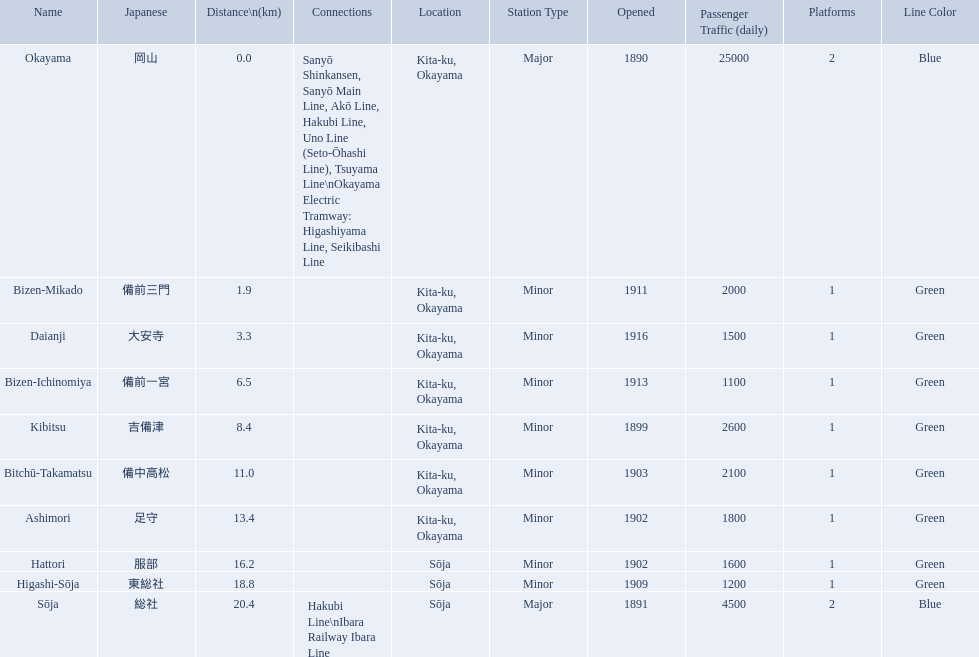What are all of the train names? Okayama, Bizen-Mikado, Daianji, Bizen-Ichinomiya, Kibitsu, Bitchū-Takamatsu, Ashimori, Hattori, Higashi-Sōja, Sōja. What is the distance for each? 0.0, 1.9, 3.3, 6.5, 8.4, 11.0, 13.4, 16.2, 18.8, 20.4. And which train's distance is between 1 and 2 km? Bizen-Mikado. What are all the stations on the kibi line? Okayama, Bizen-Mikado, Daianji, Bizen-Ichinomiya, Kibitsu, Bitchū-Takamatsu, Ashimori, Hattori, Higashi-Sōja, Sōja. What are the distances of these stations from the start of the line? 0.0, 1.9, 3.3, 6.5, 8.4, 11.0, 13.4, 16.2, 18.8, 20.4. Of these, which is larger than 1 km? 1.9, 3.3, 6.5, 8.4, 11.0, 13.4, 16.2, 18.8, 20.4. Of these, which is smaller than 2 km? 1.9. Which station is this distance from the start of the line? Bizen-Mikado. Would you mind parsing the complete table? {'header': ['Name', 'Japanese', 'Distance\\n(km)', 'Connections', 'Location', 'Station Type', 'Opened', 'Passenger Traffic (daily)', 'Platforms', 'Line Color'], 'rows': [['Okayama', '岡山', '0.0', 'Sanyō Shinkansen, Sanyō Main Line, Akō Line, Hakubi Line, Uno Line (Seto-Ōhashi Line), Tsuyama Line\\nOkayama Electric Tramway: Higashiyama Line, Seikibashi Line', 'Kita-ku, Okayama', 'Major', '1890', '25000', '2', 'Blue'], ['Bizen-Mikado', '備前三門', '1.9', '', 'Kita-ku, Okayama', 'Minor', '1911', '2000', '1', 'Green'], ['Daianji', '大安寺', '3.3', '', 'Kita-ku, Okayama', 'Minor', '1916', '1500', '1', 'Green'], ['Bizen-Ichinomiya', '備前一宮', '6.5', '', 'Kita-ku, Okayama', 'Minor', '1913', '1100', '1', 'Green'], ['Kibitsu', '吉備津', '8.4', '', 'Kita-ku, Okayama', 'Minor', '1899', '2600', '1', 'Green'], ['Bitchū-Takamatsu', '備中高松', '11.0', '', 'Kita-ku, Okayama', 'Minor', '1903', '2100', '1', 'Green'], ['Ashimori', '足守', '13.4', '', 'Kita-ku, Okayama', 'Minor', '1902', '1800', '1', 'Green'], ['Hattori', '服部', '16.2', '', 'Sōja', 'Minor', '1902', '1600', '1', 'Green'], ['Higashi-Sōja', '東総社', '18.8', '', 'Sōja', 'Minor', '1909', '1200', '1', 'Green'], ['Sōja', '総社', '20.4', 'Hakubi Line\\nIbara Railway Ibara Line', 'Sōja', 'Major', '1891', '4500', '2', 'Blue']]} 